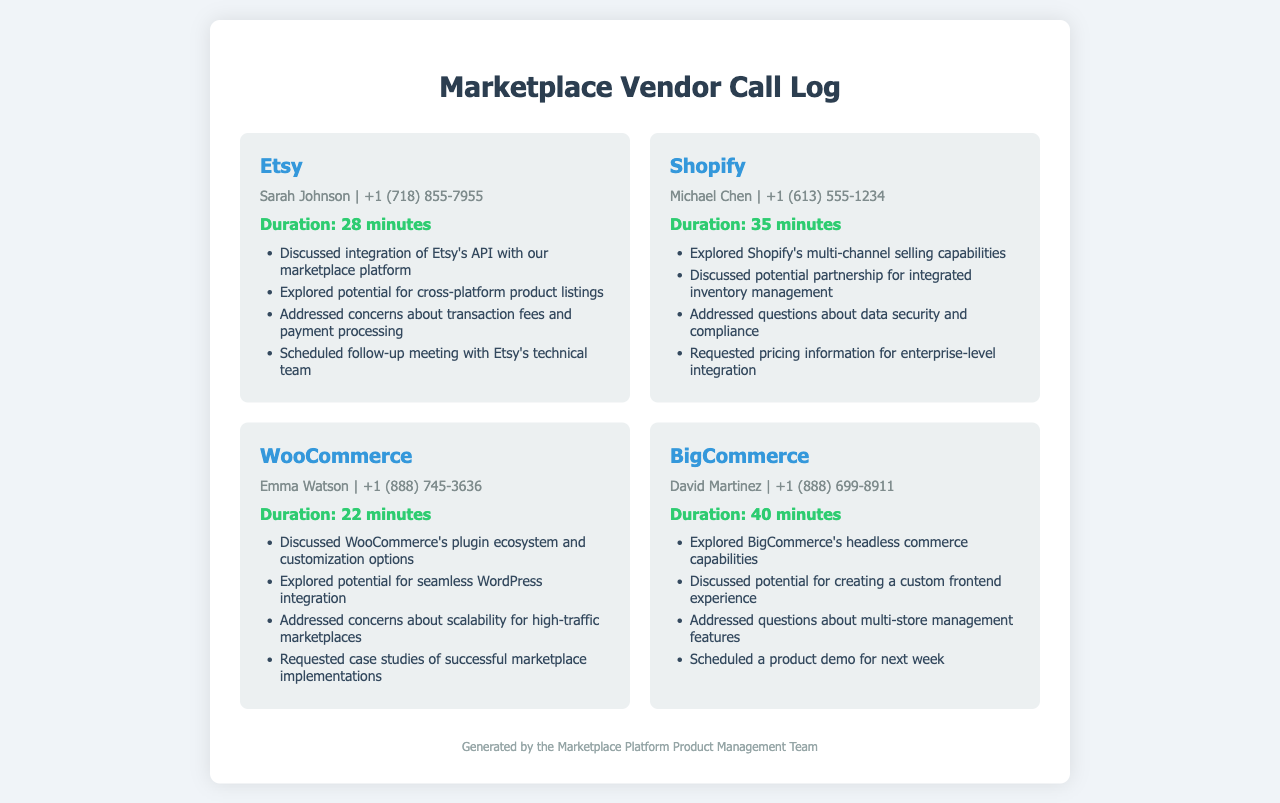What is the name of the first vendor? The first vendor listed in the document is Etsy.
Answer: Etsy How long was the call with Shopify? The duration of the call with Shopify is explicitly stated in the document.
Answer: 35 minutes Who did Emma Watson represent in the conversation? The document lists WooCommerce as the vendor represented by Emma Watson.
Answer: WooCommerce What key point was discussed regarding BigCommerce? The document outlines several key points discussed, one being the headless commerce capabilities.
Answer: Headless commerce capabilities How many minutes did the call with Etsy last? The duration of the call with Etsy is provided directly in the document.
Answer: 28 minutes What specific feature was addressed in the call with WooCommerce? The document mentions scalability concerns as a key point in the call with WooCommerce.
Answer: Scalability Who is the contact person for BigCommerce? The document explicitly lists the contact person for BigCommerce as David Martinez.
Answer: David Martinez What kind of partnership was discussed with Shopify? The key discussion point regarding Shopify mentions a potential partnership for integrated inventory management.
Answer: Integrated inventory management What was scheduled following the call with Etsy? The document notes that a follow-up meeting with Etsy's technical team was scheduled after the call.
Answer: Follow-up meeting 